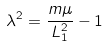<formula> <loc_0><loc_0><loc_500><loc_500>\lambda ^ { 2 } = \frac { m \mu } { L _ { 1 } ^ { 2 } } - 1</formula> 